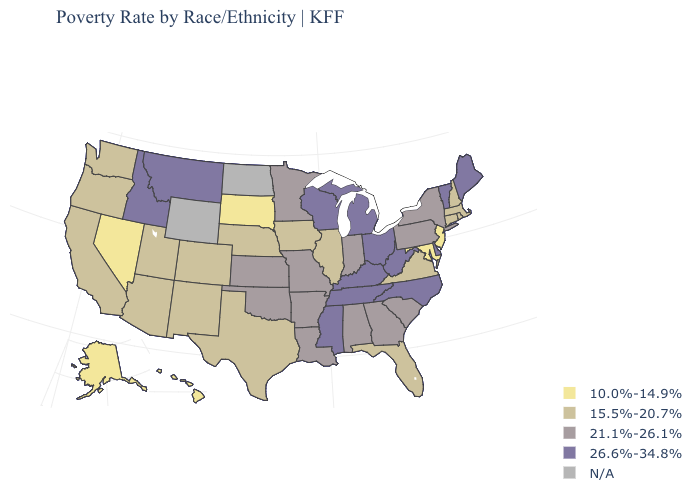Name the states that have a value in the range 10.0%-14.9%?
Quick response, please. Alaska, Hawaii, Maryland, Nevada, New Jersey, South Dakota. Name the states that have a value in the range 21.1%-26.1%?
Give a very brief answer. Alabama, Arkansas, Georgia, Indiana, Kansas, Louisiana, Minnesota, Missouri, New York, Oklahoma, Pennsylvania, South Carolina. Which states have the lowest value in the USA?
Give a very brief answer. Alaska, Hawaii, Maryland, Nevada, New Jersey, South Dakota. What is the lowest value in states that border New York?
Answer briefly. 10.0%-14.9%. Does Washington have the highest value in the USA?
Give a very brief answer. No. Among the states that border Florida , which have the lowest value?
Answer briefly. Alabama, Georgia. What is the value of New Hampshire?
Answer briefly. 15.5%-20.7%. Name the states that have a value in the range 15.5%-20.7%?
Be succinct. Arizona, California, Colorado, Connecticut, Florida, Illinois, Iowa, Massachusetts, Nebraska, New Hampshire, New Mexico, Oregon, Rhode Island, Texas, Utah, Virginia, Washington. What is the lowest value in the USA?
Be succinct. 10.0%-14.9%. Does the first symbol in the legend represent the smallest category?
Be succinct. Yes. What is the value of New Jersey?
Be succinct. 10.0%-14.9%. Which states have the lowest value in the USA?
Quick response, please. Alaska, Hawaii, Maryland, Nevada, New Jersey, South Dakota. Name the states that have a value in the range 26.6%-34.8%?
Short answer required. Delaware, Idaho, Kentucky, Maine, Michigan, Mississippi, Montana, North Carolina, Ohio, Tennessee, Vermont, West Virginia, Wisconsin. 